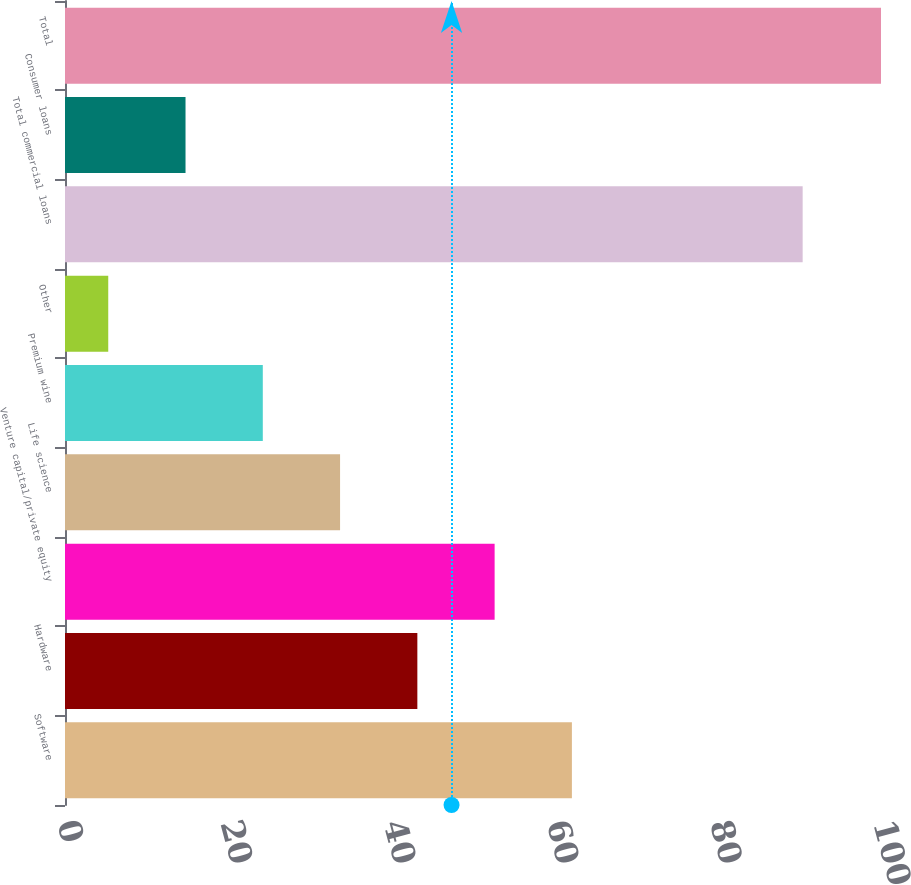Convert chart. <chart><loc_0><loc_0><loc_500><loc_500><bar_chart><fcel>Software<fcel>Hardware<fcel>Venture capital/private equity<fcel>Life science<fcel>Premium wine<fcel>Other<fcel>Total commercial loans<fcel>Consumer loans<fcel>Total<nl><fcel>62.12<fcel>43.18<fcel>52.65<fcel>33.71<fcel>24.24<fcel>5.3<fcel>90.4<fcel>14.77<fcel>100<nl></chart> 